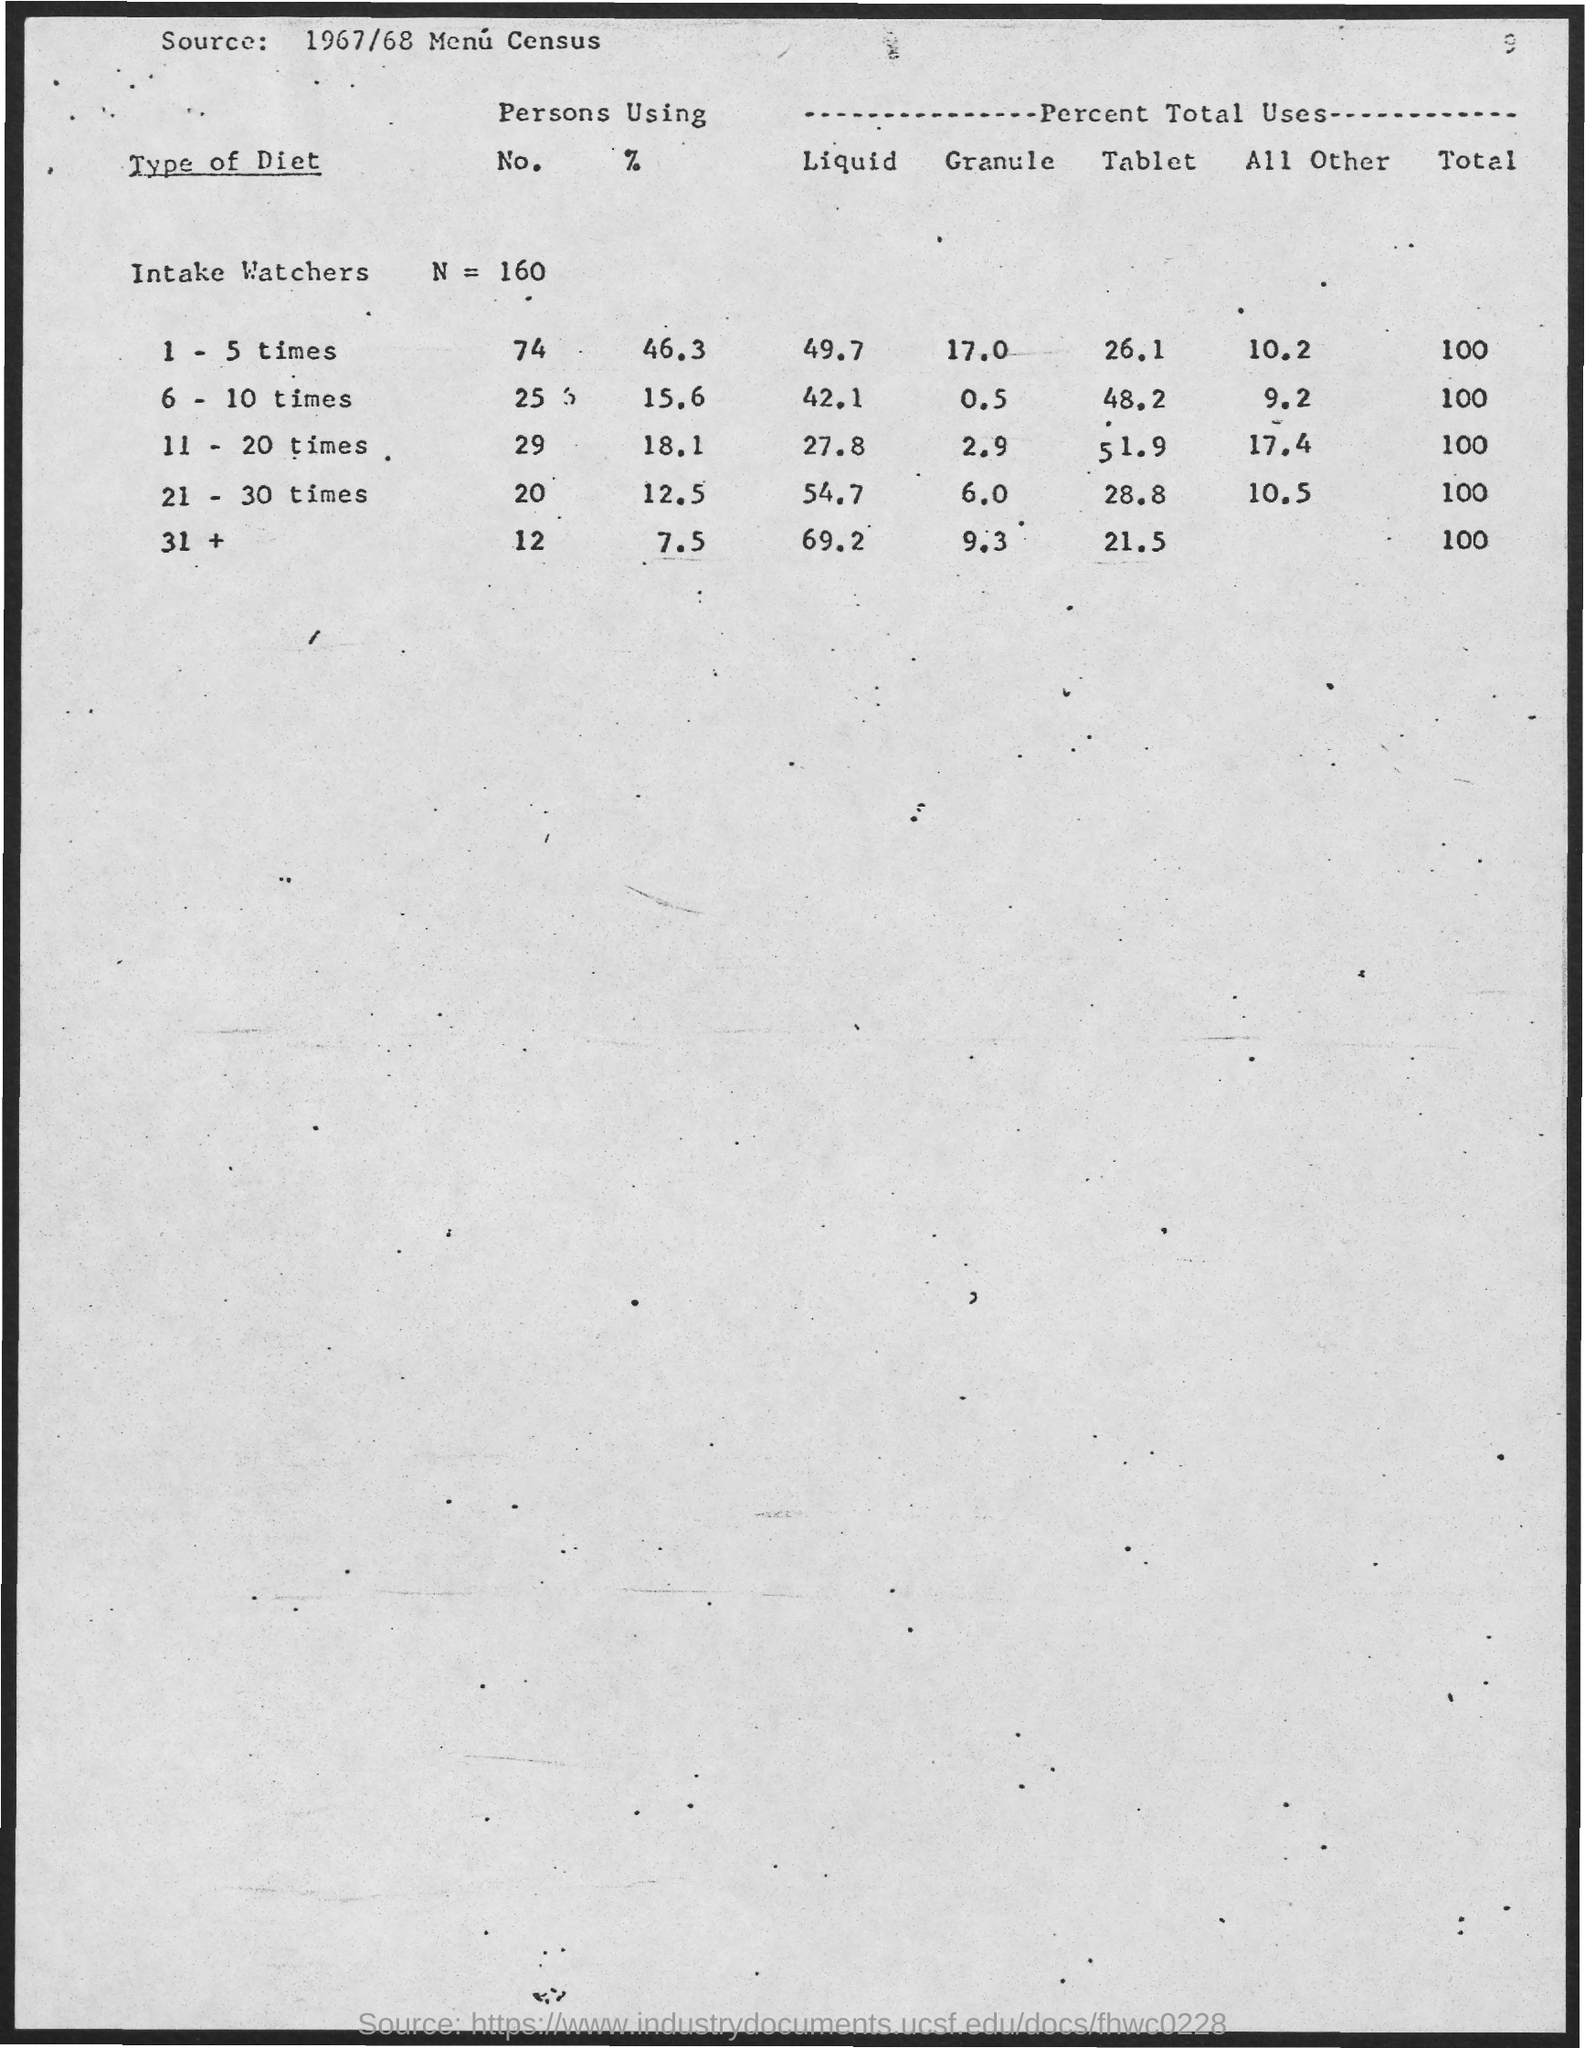Point out several critical features in this image. The value of N is 160. 